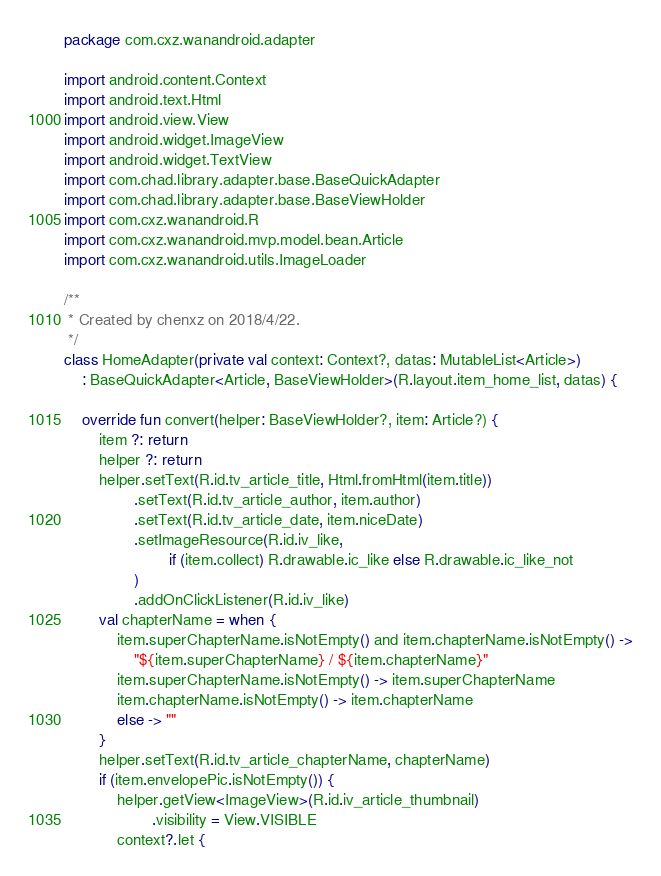Convert code to text. <code><loc_0><loc_0><loc_500><loc_500><_Kotlin_>package com.cxz.wanandroid.adapter

import android.content.Context
import android.text.Html
import android.view.View
import android.widget.ImageView
import android.widget.TextView
import com.chad.library.adapter.base.BaseQuickAdapter
import com.chad.library.adapter.base.BaseViewHolder
import com.cxz.wanandroid.R
import com.cxz.wanandroid.mvp.model.bean.Article
import com.cxz.wanandroid.utils.ImageLoader

/**
 * Created by chenxz on 2018/4/22.
 */
class HomeAdapter(private val context: Context?, datas: MutableList<Article>)
    : BaseQuickAdapter<Article, BaseViewHolder>(R.layout.item_home_list, datas) {

    override fun convert(helper: BaseViewHolder?, item: Article?) {
        item ?: return
        helper ?: return
        helper.setText(R.id.tv_article_title, Html.fromHtml(item.title))
                .setText(R.id.tv_article_author, item.author)
                .setText(R.id.tv_article_date, item.niceDate)
                .setImageResource(R.id.iv_like,
                        if (item.collect) R.drawable.ic_like else R.drawable.ic_like_not
                )
                .addOnClickListener(R.id.iv_like)
        val chapterName = when {
            item.superChapterName.isNotEmpty() and item.chapterName.isNotEmpty() ->
                "${item.superChapterName} / ${item.chapterName}"
            item.superChapterName.isNotEmpty() -> item.superChapterName
            item.chapterName.isNotEmpty() -> item.chapterName
            else -> ""
        }
        helper.setText(R.id.tv_article_chapterName, chapterName)
        if (item.envelopePic.isNotEmpty()) {
            helper.getView<ImageView>(R.id.iv_article_thumbnail)
                    .visibility = View.VISIBLE
            context?.let {</code> 